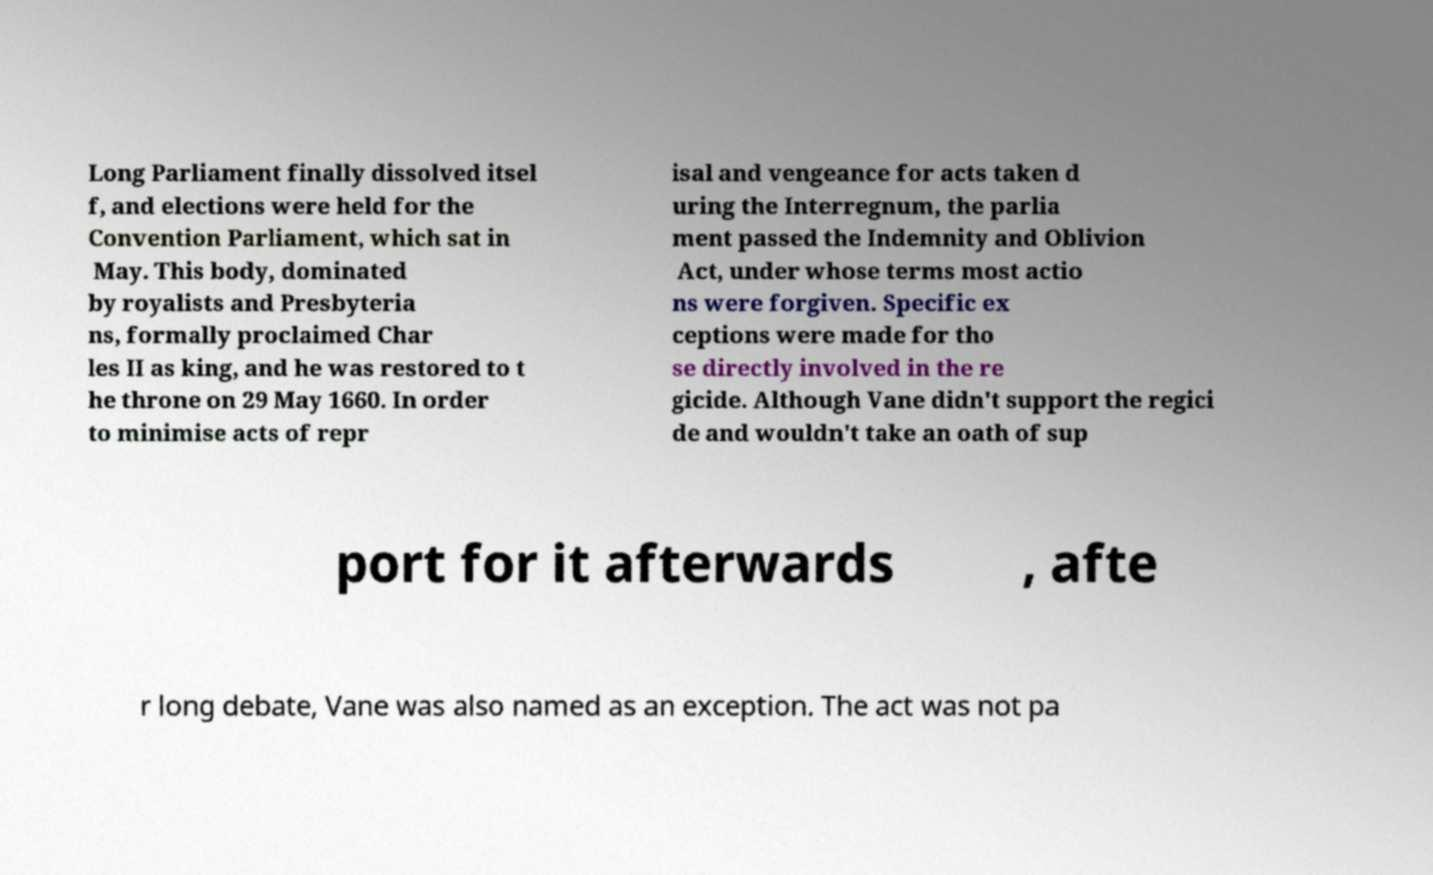What messages or text are displayed in this image? I need them in a readable, typed format. Long Parliament finally dissolved itsel f, and elections were held for the Convention Parliament, which sat in May. This body, dominated by royalists and Presbyteria ns, formally proclaimed Char les II as king, and he was restored to t he throne on 29 May 1660. In order to minimise acts of repr isal and vengeance for acts taken d uring the Interregnum, the parlia ment passed the Indemnity and Oblivion Act, under whose terms most actio ns were forgiven. Specific ex ceptions were made for tho se directly involved in the re gicide. Although Vane didn't support the regici de and wouldn't take an oath of sup port for it afterwards , afte r long debate, Vane was also named as an exception. The act was not pa 